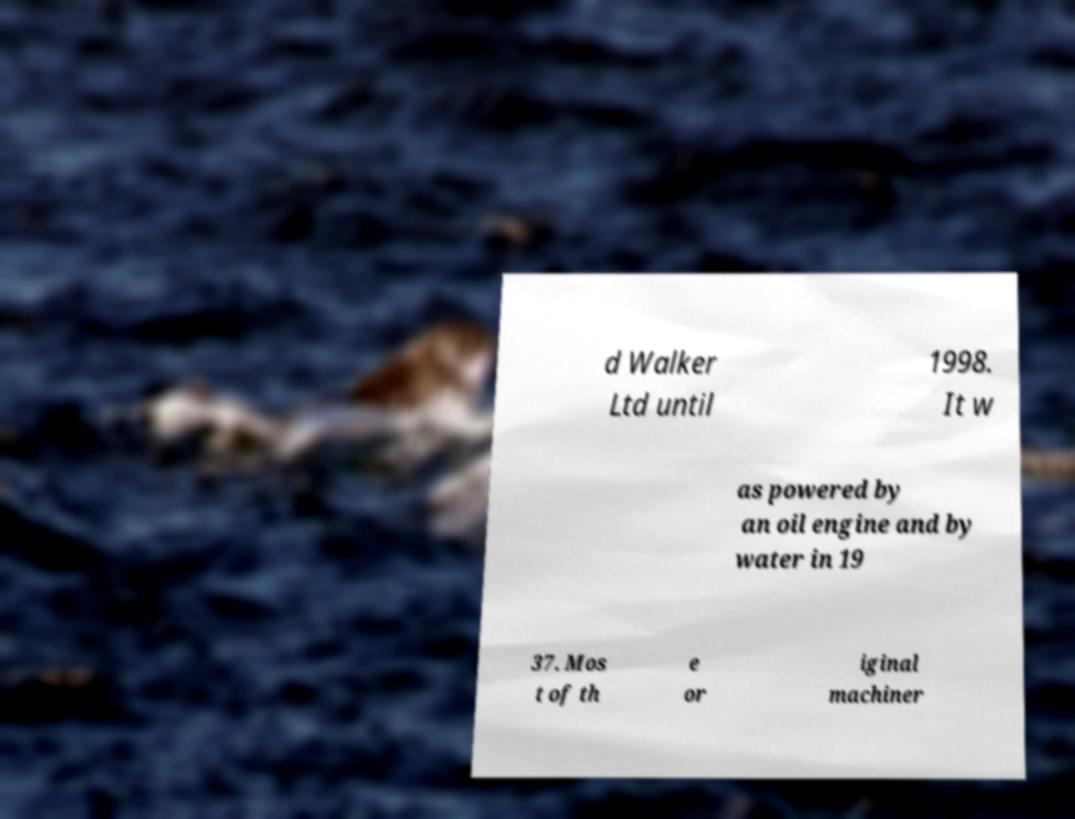Please read and relay the text visible in this image. What does it say? d Walker Ltd until 1998. It w as powered by an oil engine and by water in 19 37. Mos t of th e or iginal machiner 